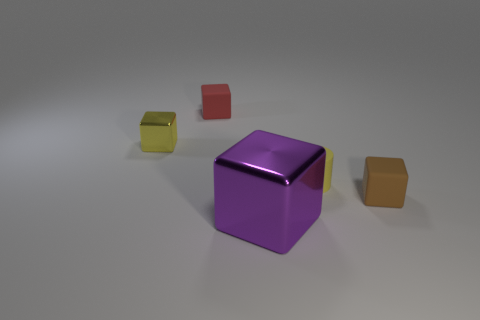Is there anything else that is the same size as the purple metal block?
Your answer should be very brief. No. There is another metal thing that is the same shape as the yellow metal object; what color is it?
Offer a terse response. Purple. How many tiny cylinders are the same color as the large metallic object?
Offer a very short reply. 0. There is a yellow object that is to the right of the large cube; does it have the same shape as the brown object?
Your response must be concise. No. There is a tiny yellow thing that is on the right side of the metallic cube in front of the yellow thing that is on the left side of the small red object; what is its shape?
Keep it short and to the point. Cylinder. The yellow rubber cylinder has what size?
Provide a short and direct response. Small. There is a cylinder that is the same material as the brown cube; what color is it?
Provide a short and direct response. Yellow. How many tiny yellow things have the same material as the small red object?
Keep it short and to the point. 1. There is a big metallic block; does it have the same color as the matte block behind the tiny brown cube?
Offer a very short reply. No. What is the color of the shiny thing in front of the metallic block left of the tiny red cube?
Offer a very short reply. Purple. 